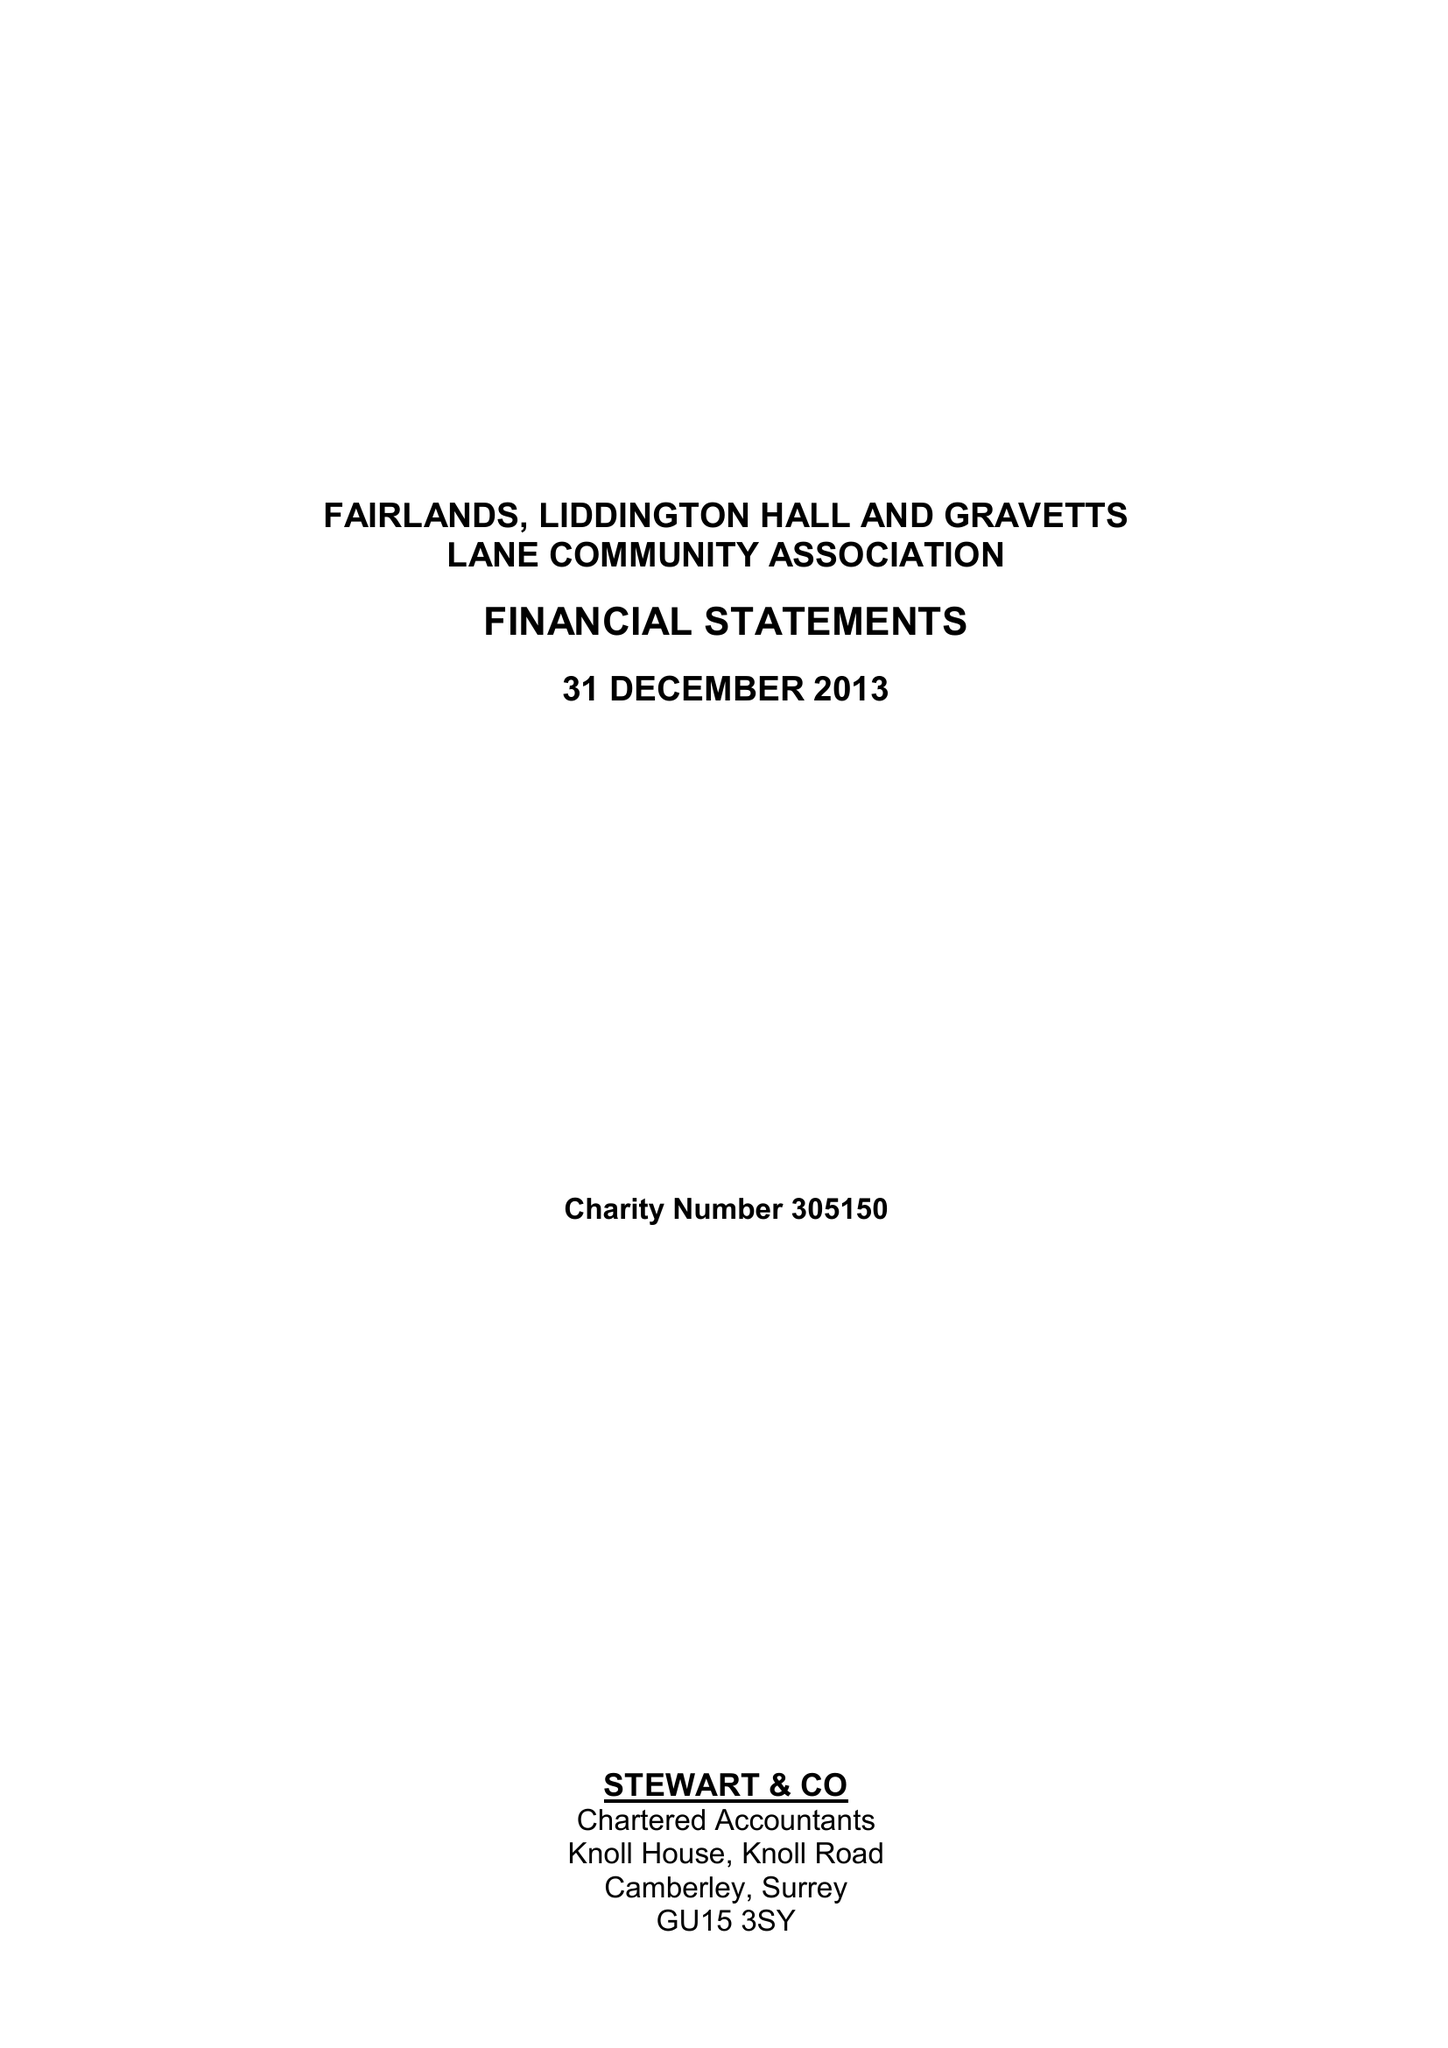What is the value for the charity_name?
Answer the question using a single word or phrase. Fairlands Liddington Hall and Gravetts Lane Community Association 